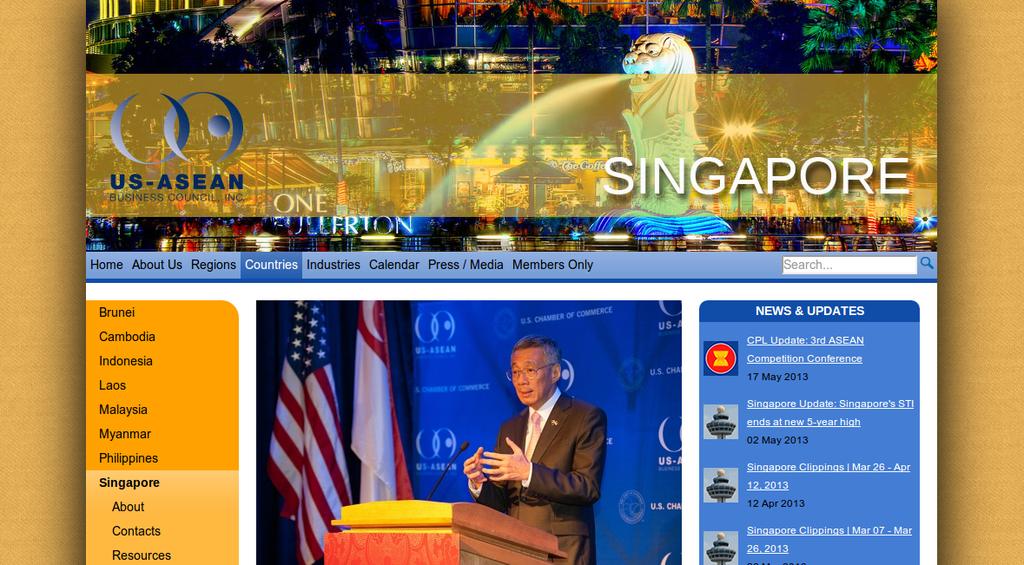What is the second link on the navigation bar of this website?
Provide a succinct answer. About us. What country is mentioned?
Keep it short and to the point. Singapore. 